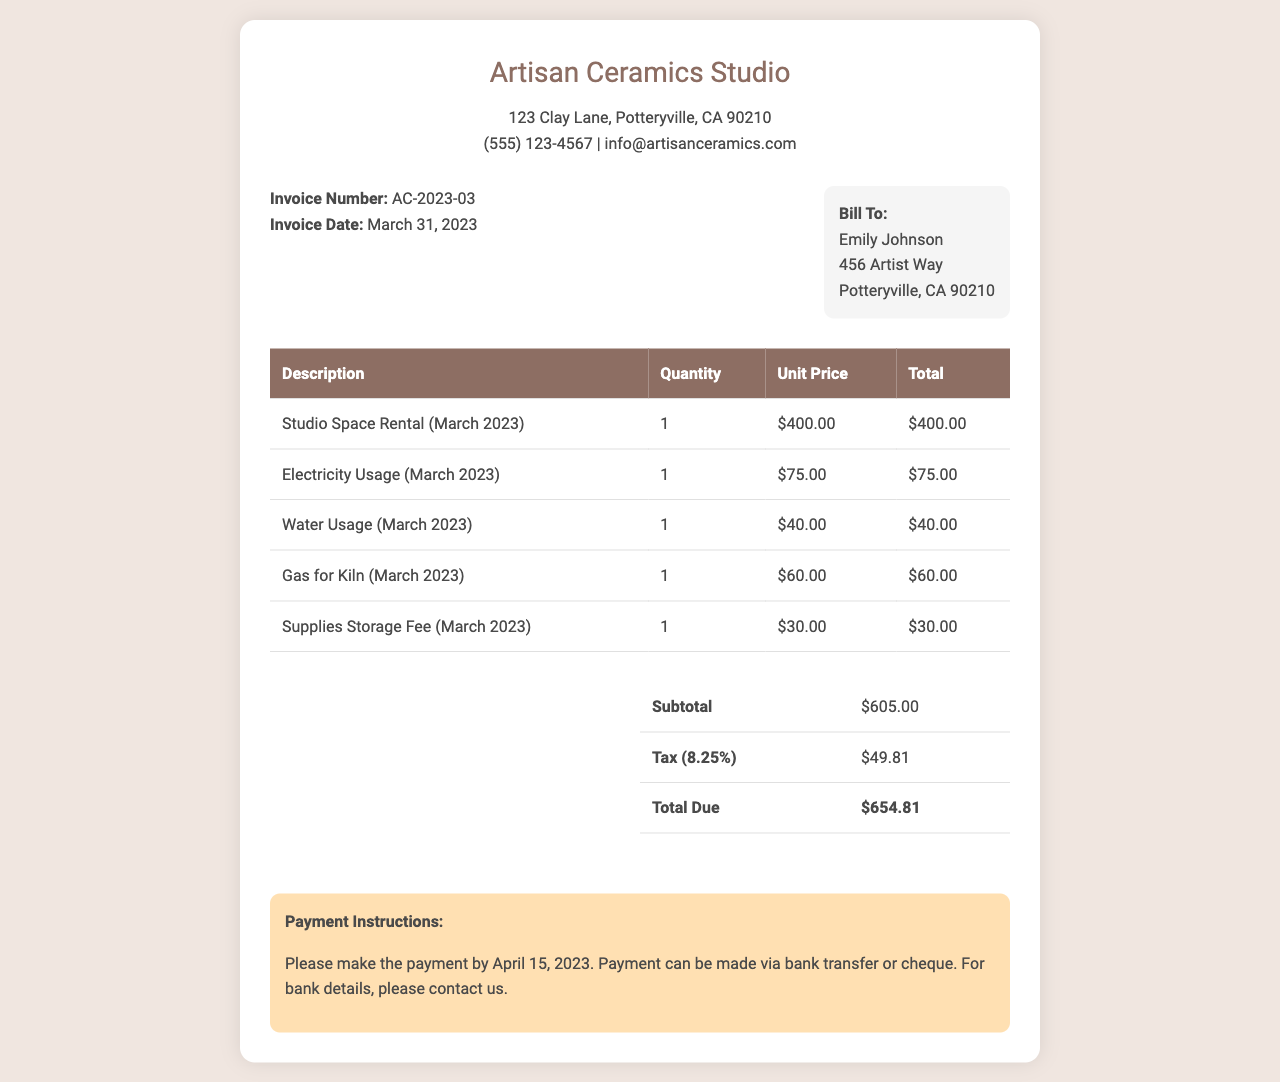What is the invoice number? The invoice number is listed at the top of the invoice, identifying this particular document.
Answer: AC-2023-03 What is the total due amount? The total due amount is found at the end of the invoice, summarizing all charges and taxes.
Answer: $654.81 Who is the bill to? The bill to section provides the name of the person receiving the invoice.
Answer: Emily Johnson What is the subtotal before tax? The subtotal is before adding the tax, providing the total of the services and fees.
Answer: $605.00 How much is the tax rate applied in this invoice? The tax rate is stated on the invoice and is used to calculate the total amount due.
Answer: 8.25% What item has the highest charge? The items listed show various charges; identifying the highest helps understand costs better.
Answer: Studio Space Rental (March 2023) When is the payment due? The payment instructions specify when the payment should be completed to avoid late fees.
Answer: April 15, 2023 What is the charge for electricity usage? The charge specifically outlined for electricity usage can provide insight into utility costs.
Answer: $75.00 What services are included in this invoice? This invoice includes various services that contribute to the total amount due, reflecting the usage of the studio.
Answer: Studio Space Rental, Electricity Usage, Water Usage, Gas for Kiln, Supplies Storage Fee 